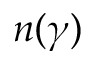Convert formula to latex. <formula><loc_0><loc_0><loc_500><loc_500>n ( \gamma )</formula> 